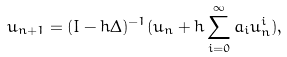Convert formula to latex. <formula><loc_0><loc_0><loc_500><loc_500>u _ { n + 1 } = ( I - h \Delta ) ^ { - 1 } ( u _ { n } + h \sum _ { i = 0 } ^ { \infty } a _ { i } u _ { n } ^ { i } ) ,</formula> 